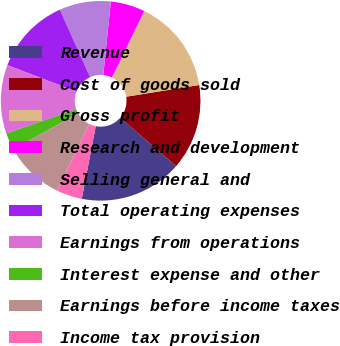<chart> <loc_0><loc_0><loc_500><loc_500><pie_chart><fcel>Revenue<fcel>Cost of goods sold<fcel>Gross profit<fcel>Research and development<fcel>Selling general and<fcel>Total operating expenses<fcel>Earnings from operations<fcel>Interest expense and other<fcel>Earnings before income taxes<fcel>Income tax provision<nl><fcel>16.67%<fcel>13.89%<fcel>15.28%<fcel>5.56%<fcel>8.33%<fcel>12.5%<fcel>11.11%<fcel>2.78%<fcel>9.72%<fcel>4.17%<nl></chart> 